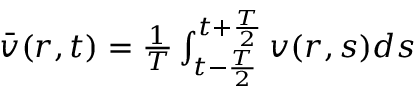Convert formula to latex. <formula><loc_0><loc_0><loc_500><loc_500>\begin{array} { r } { \ B a r { v } ( r , t ) = \frac { 1 } { T } \int _ { t - \frac { T } { 2 } } ^ { t + \frac { T } { 2 } } v ( r , s ) d s } \end{array}</formula> 